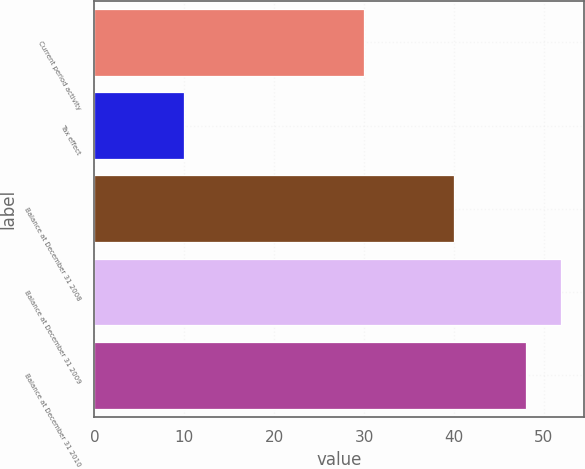Convert chart to OTSL. <chart><loc_0><loc_0><loc_500><loc_500><bar_chart><fcel>Current period activity<fcel>Tax effect<fcel>Balance at December 31 2008<fcel>Balance at December 31 2009<fcel>Balance at December 31 2010<nl><fcel>30<fcel>10<fcel>40<fcel>51.9<fcel>48<nl></chart> 